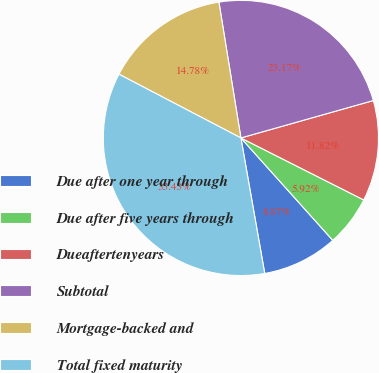Convert chart. <chart><loc_0><loc_0><loc_500><loc_500><pie_chart><fcel>Due after one year through<fcel>Due after five years through<fcel>Dueaftertenyears<fcel>Subtotal<fcel>Mortgage-backed and<fcel>Total fixed maturity<nl><fcel>8.87%<fcel>5.92%<fcel>11.82%<fcel>23.17%<fcel>14.78%<fcel>35.43%<nl></chart> 